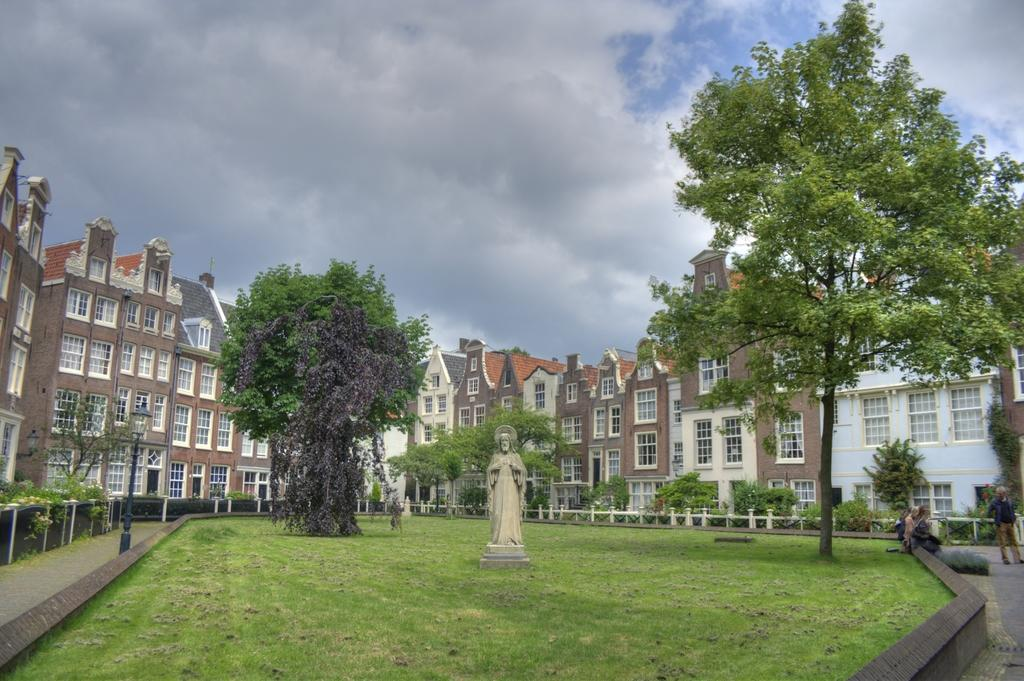What is located on the ground in the image? There is a statue on the ground in the image. What type of natural elements can be seen in the image? There are trees visible in the image. What type of man-made structures are present in the image? There are buildings in the image. What type of song is being sung by the statue in the image? There is no indication in the image that the statue is singing a song, as statues are typically inanimate objects. 